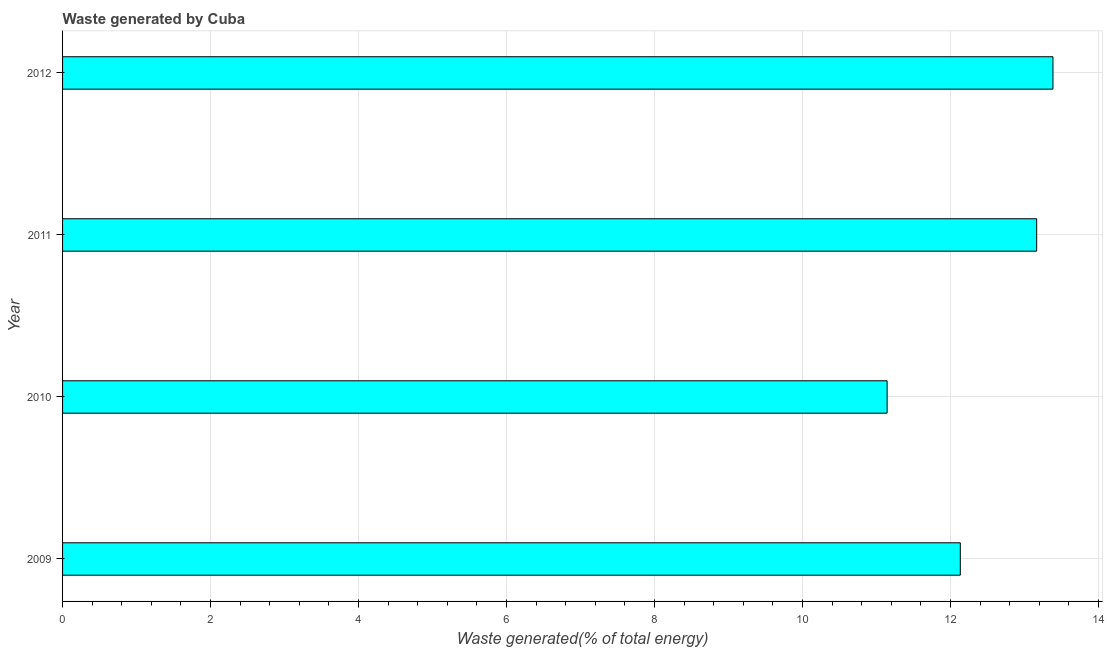What is the title of the graph?
Your response must be concise. Waste generated by Cuba. What is the label or title of the X-axis?
Ensure brevity in your answer.  Waste generated(% of total energy). What is the label or title of the Y-axis?
Provide a short and direct response. Year. What is the amount of waste generated in 2009?
Your answer should be very brief. 12.13. Across all years, what is the maximum amount of waste generated?
Give a very brief answer. 13.38. Across all years, what is the minimum amount of waste generated?
Keep it short and to the point. 11.14. In which year was the amount of waste generated maximum?
Provide a short and direct response. 2012. In which year was the amount of waste generated minimum?
Keep it short and to the point. 2010. What is the sum of the amount of waste generated?
Your response must be concise. 49.82. What is the difference between the amount of waste generated in 2009 and 2012?
Make the answer very short. -1.25. What is the average amount of waste generated per year?
Provide a succinct answer. 12.46. What is the median amount of waste generated?
Keep it short and to the point. 12.65. In how many years, is the amount of waste generated greater than 11.6 %?
Your answer should be compact. 3. Do a majority of the years between 2009 and 2011 (inclusive) have amount of waste generated greater than 1.2 %?
Offer a terse response. Yes. What is the ratio of the amount of waste generated in 2011 to that in 2012?
Provide a succinct answer. 0.98. Is the amount of waste generated in 2009 less than that in 2011?
Provide a succinct answer. Yes. Is the difference between the amount of waste generated in 2009 and 2010 greater than the difference between any two years?
Keep it short and to the point. No. What is the difference between the highest and the second highest amount of waste generated?
Your response must be concise. 0.22. What is the difference between the highest and the lowest amount of waste generated?
Make the answer very short. 2.24. How many bars are there?
Provide a short and direct response. 4. How many years are there in the graph?
Your answer should be very brief. 4. What is the difference between two consecutive major ticks on the X-axis?
Give a very brief answer. 2. Are the values on the major ticks of X-axis written in scientific E-notation?
Ensure brevity in your answer.  No. What is the Waste generated(% of total energy) of 2009?
Offer a very short reply. 12.13. What is the Waste generated(% of total energy) of 2010?
Your answer should be compact. 11.14. What is the Waste generated(% of total energy) in 2011?
Your answer should be very brief. 13.16. What is the Waste generated(% of total energy) in 2012?
Provide a succinct answer. 13.38. What is the difference between the Waste generated(% of total energy) in 2009 and 2010?
Your response must be concise. 0.99. What is the difference between the Waste generated(% of total energy) in 2009 and 2011?
Your answer should be compact. -1.03. What is the difference between the Waste generated(% of total energy) in 2009 and 2012?
Offer a very short reply. -1.25. What is the difference between the Waste generated(% of total energy) in 2010 and 2011?
Provide a short and direct response. -2.02. What is the difference between the Waste generated(% of total energy) in 2010 and 2012?
Keep it short and to the point. -2.24. What is the difference between the Waste generated(% of total energy) in 2011 and 2012?
Offer a very short reply. -0.22. What is the ratio of the Waste generated(% of total energy) in 2009 to that in 2010?
Keep it short and to the point. 1.09. What is the ratio of the Waste generated(% of total energy) in 2009 to that in 2011?
Provide a succinct answer. 0.92. What is the ratio of the Waste generated(% of total energy) in 2009 to that in 2012?
Keep it short and to the point. 0.91. What is the ratio of the Waste generated(% of total energy) in 2010 to that in 2011?
Offer a very short reply. 0.85. What is the ratio of the Waste generated(% of total energy) in 2010 to that in 2012?
Your answer should be very brief. 0.83. What is the ratio of the Waste generated(% of total energy) in 2011 to that in 2012?
Provide a succinct answer. 0.98. 